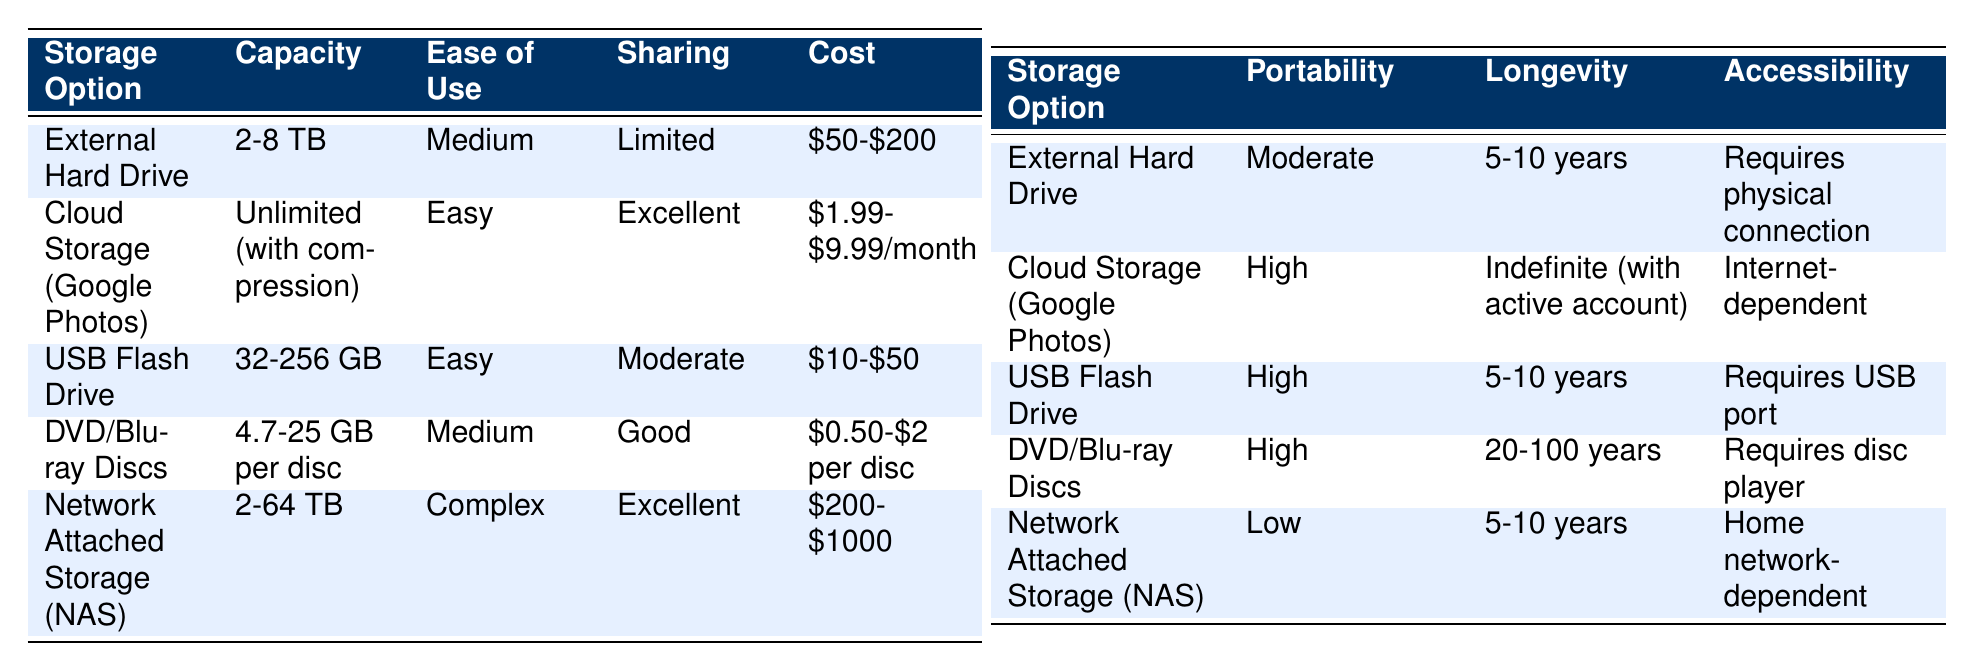What is the cost range for cloud storage? The cost range for cloud storage listed in the table is between $1.99 and $9.99 per month.
Answer: $1.99-$9.99/month Which storage option has the highest portability? Cloud storage, USB flash drive, and DVD/Blu-ray discs all have high portability. This means they can be easily moved or accessed from different locations.
Answer: Cloud storage, USB flash drive, and DVD/Blu-ray discs Is the longevity of DVD/Blu-ray discs longer than that of an external hard drive? Yes, DVD/Blu-ray discs have a longevity of 20-100 years, whereas an external hard drive only lasts 5-10 years.
Answer: Yes What is the average capacity of USB flash drives and external hard drives combined? The average capacity can be found by adding the capacities of USB flash drives (144 GB average from 32-256 GB) and external hard drives (5 TB average from 2-8 TB), then dividing the sum by 2. This is (5 TB + 144 GB) = 5,144 GB which divided by 2 equals approximately 2,572 GB.
Answer: 2,572 GB Is cloud storage internet-dependent and does it make sharing easier? Yes, cloud storage is internet-dependent and allows for excellent sharing capabilities, enabling easy access and sharing with others through the internet.
Answer: Yes Which storage option has a manual backup and moderate sharing capability? The USB flash drive has a manual backup and moderate sharing capability according to the table provided.
Answer: USB flash drive What is the lowest cost storage option? The lowest cost option listed is the DVD/Blu-ray discs, which cost between $0.50 and $2 per disc.
Answer: $0.50-$2 per disc Which storage solution has the most complex ease of use? The Network Attached Storage (NAS) option has a complex ease of use according to the table, indicating it may require more technical knowledge to operate.
Answer: Network Attached Storage (NAS) How does the sharing capability compare between cloud storage and external hard drives? Cloud storage offers excellent sharing capability, while external hard drives have limited sharing capability. This suggests that cloud storage is superior for sharing.
Answer: Cloud storage is better for sharing 